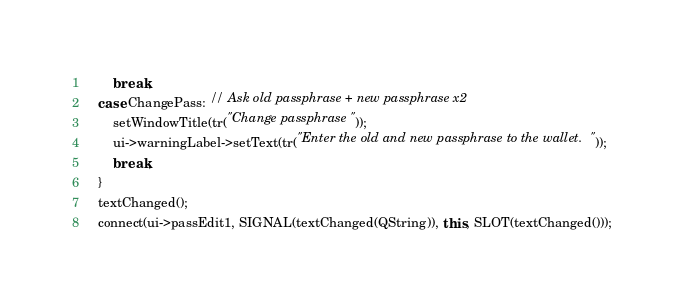<code> <loc_0><loc_0><loc_500><loc_500><_C++_>        break;
    case ChangePass: // Ask old passphrase + new passphrase x2
        setWindowTitle(tr("Change passphrase"));
        ui->warningLabel->setText(tr("Enter the old and new passphrase to the wallet."));
        break;
    }
    textChanged();
    connect(ui->passEdit1, SIGNAL(textChanged(QString)), this, SLOT(textChanged()));</code> 